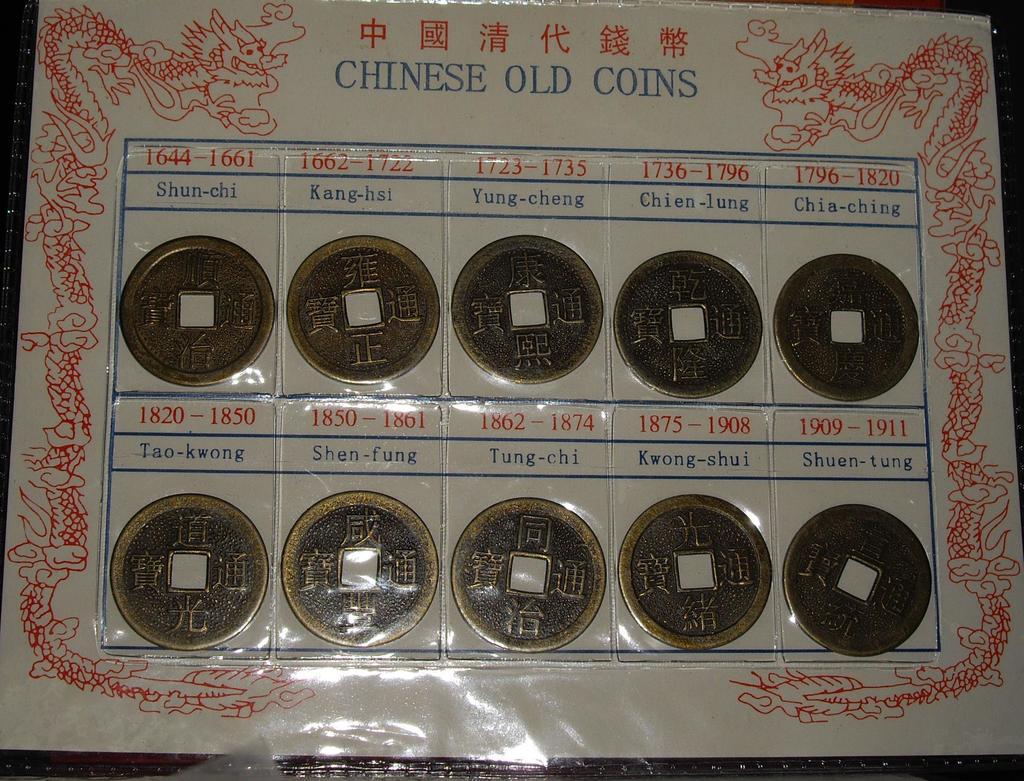What type of coins are these?
Ensure brevity in your answer.  Chinese old coins. What is the middle word along the top?
Provide a short and direct response. Old. 